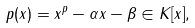Convert formula to latex. <formula><loc_0><loc_0><loc_500><loc_500>p ( x ) = x ^ { p } - \alpha x - \beta \in K [ x ] ,</formula> 